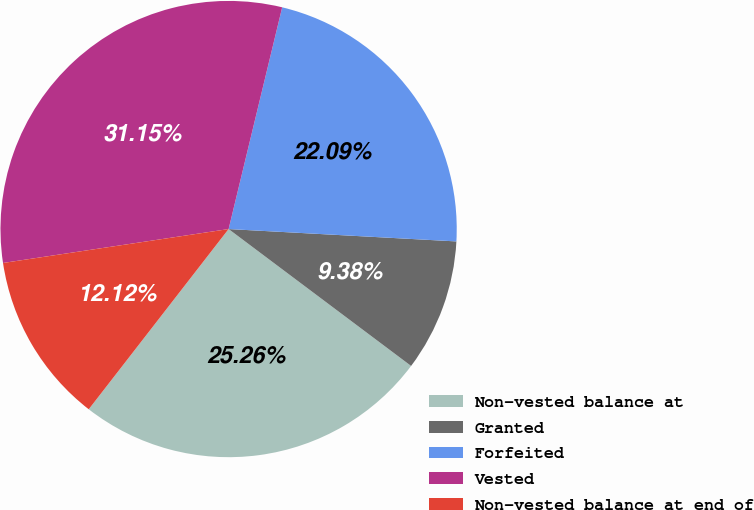Convert chart. <chart><loc_0><loc_0><loc_500><loc_500><pie_chart><fcel>Non-vested balance at<fcel>Granted<fcel>Forfeited<fcel>Vested<fcel>Non-vested balance at end of<nl><fcel>25.26%<fcel>9.38%<fcel>22.09%<fcel>31.15%<fcel>12.12%<nl></chart> 